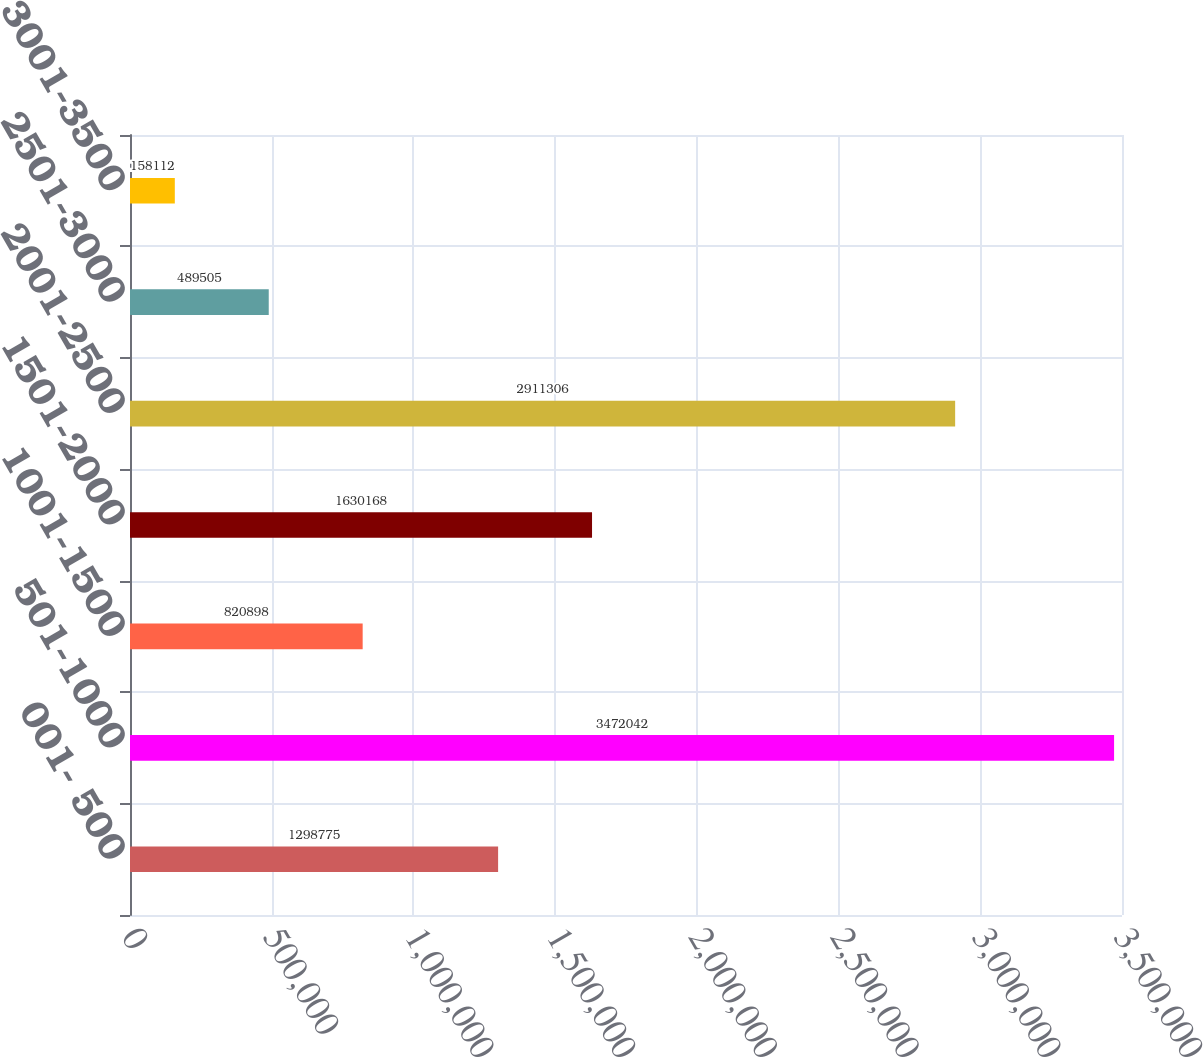Convert chart to OTSL. <chart><loc_0><loc_0><loc_500><loc_500><bar_chart><fcel>001- 500<fcel>501-1000<fcel>1001-1500<fcel>1501-2000<fcel>2001-2500<fcel>2501-3000<fcel>3001-3500<nl><fcel>1.29878e+06<fcel>3.47204e+06<fcel>820898<fcel>1.63017e+06<fcel>2.91131e+06<fcel>489505<fcel>158112<nl></chart> 